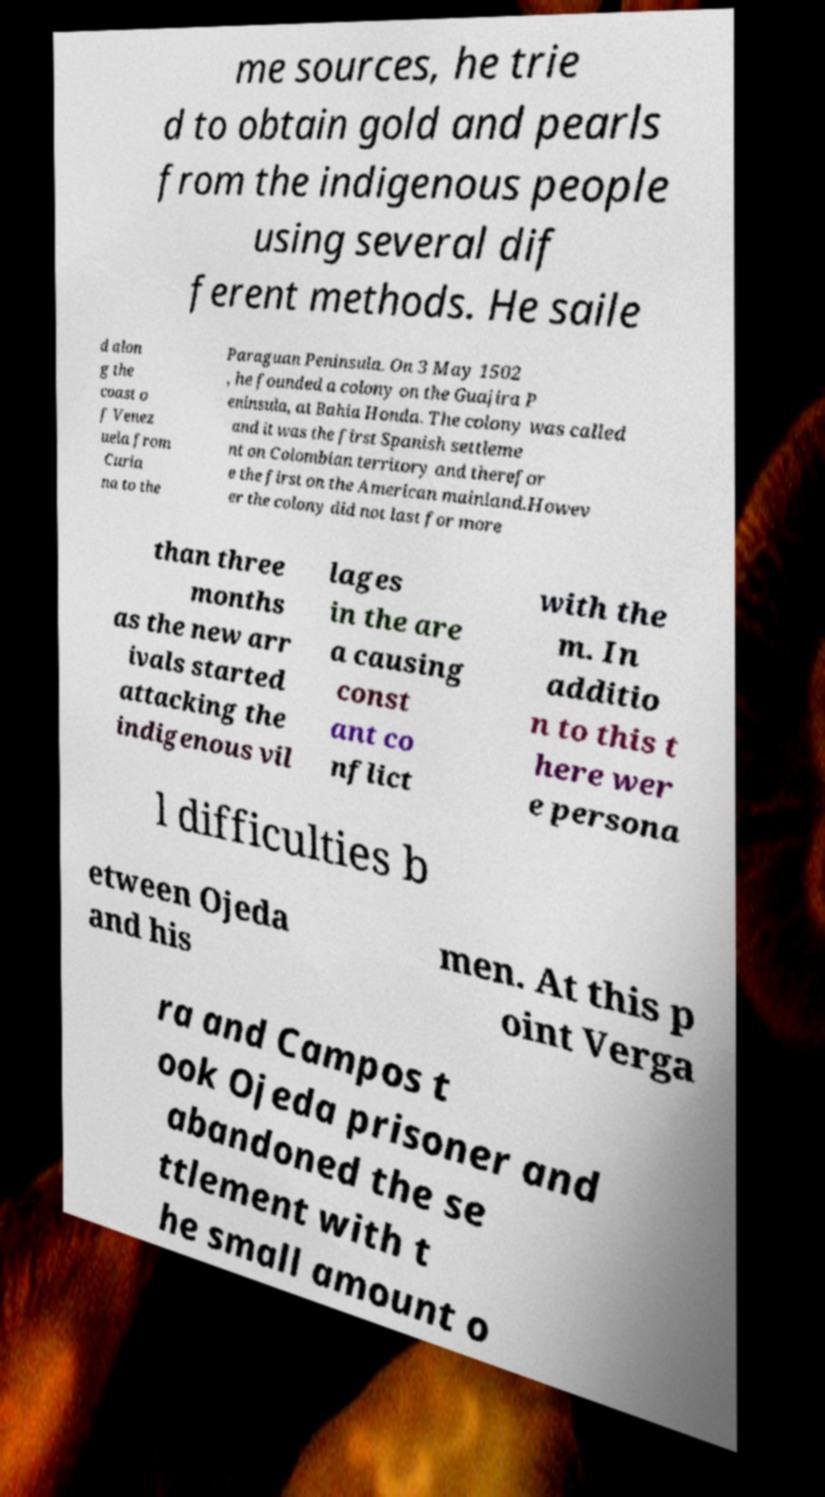For documentation purposes, I need the text within this image transcribed. Could you provide that? me sources, he trie d to obtain gold and pearls from the indigenous people using several dif ferent methods. He saile d alon g the coast o f Venez uela from Curia na to the Paraguan Peninsula. On 3 May 1502 , he founded a colony on the Guajira P eninsula, at Bahia Honda. The colony was called and it was the first Spanish settleme nt on Colombian territory and therefor e the first on the American mainland.Howev er the colony did not last for more than three months as the new arr ivals started attacking the indigenous vil lages in the are a causing const ant co nflict with the m. In additio n to this t here wer e persona l difficulties b etween Ojeda and his men. At this p oint Verga ra and Campos t ook Ojeda prisoner and abandoned the se ttlement with t he small amount o 